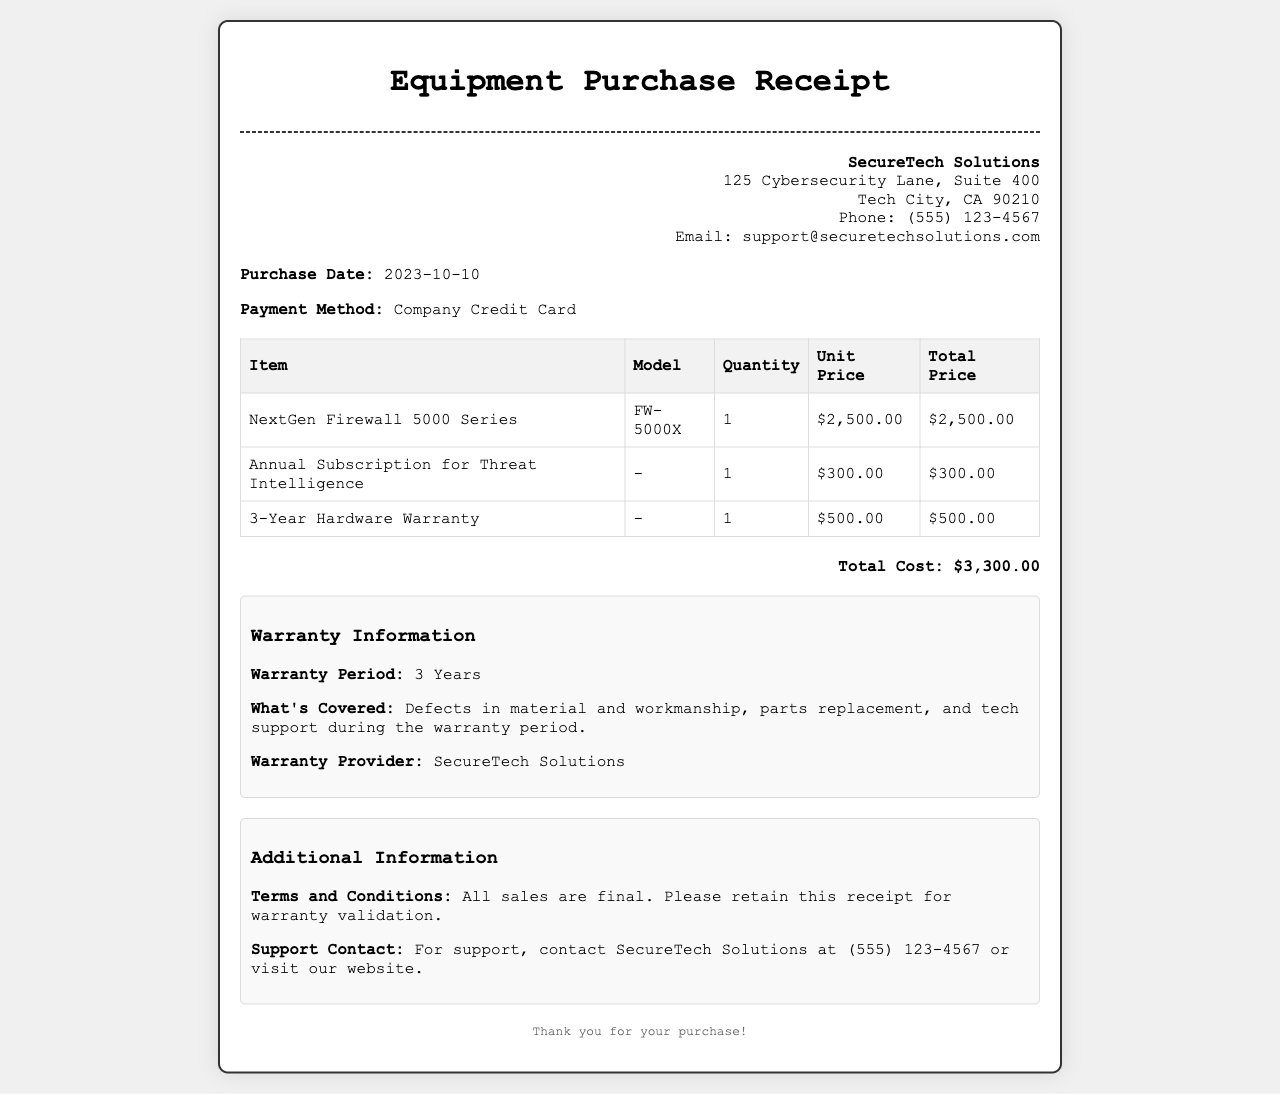What is the vendor name? The vendor name is listed at the top right corner of the document, which states "SecureTech Solutions."
Answer: SecureTech Solutions What is the total cost of the equipment purchased? The total cost is provided at the bottom of the receipt, showing "Total Cost: $3,300.00."
Answer: $3,300.00 When was the purchase made? The purchase date can be found in the document under the purchase info section, stating "2023-10-10."
Answer: 2023-10-10 What type of payment method was used? The payment method is specified in the purchase info section, which mentions "Company Credit Card."
Answer: Company Credit Card What is covered under the warranty? The warranty information section outlines that it covers "Defects in material and workmanship, parts replacement, and tech support during the warranty period."
Answer: Defects in material and workmanship, parts replacement, and tech support How long is the warranty period? The warranty period is detailed in the warranty information section, listing "3 Years."
Answer: 3 Years What item has a unit price of $2,500.00? The document indicates that "NextGen Firewall 5000 Series" has a unit price of "$2,500.00."
Answer: NextGen Firewall 5000 Series What additional service was purchased with the equipment? Under the item list, the document shows "Annual Subscription for Threat Intelligence" as an additional service.
Answer: Annual Subscription for Threat Intelligence Who can be contacted for support? The additional information section provides a support contact stating "SecureTech Solutions at (555) 123-4567."
Answer: SecureTech Solutions at (555) 123-4567 